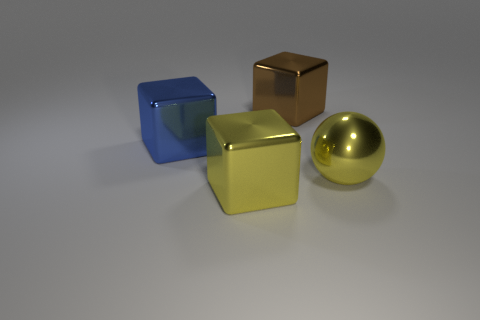How many big objects are blue metallic blocks or yellow objects?
Your response must be concise. 3. What size is the block that is behind the block on the left side of the big yellow object that is to the left of the brown cube?
Offer a terse response. Large. Is there anything else of the same color as the sphere?
Offer a terse response. Yes. The large blue thing behind the metal ball that is on the right side of the metal cube in front of the large yellow ball is made of what material?
Your answer should be compact. Metal. Is the brown object the same shape as the big blue object?
Provide a short and direct response. Yes. Is there anything else that has the same material as the brown thing?
Your response must be concise. Yes. What number of objects are to the left of the yellow shiny block and right of the blue thing?
Offer a terse response. 0. The big object that is right of the large object behind the big blue cube is what color?
Provide a succinct answer. Yellow. Is the number of large yellow shiny cubes that are to the left of the big blue shiny block the same as the number of large rubber balls?
Your answer should be very brief. Yes. There is a yellow metal thing that is to the left of the big metallic block behind the big blue object; how many large yellow metal things are behind it?
Keep it short and to the point. 1. 